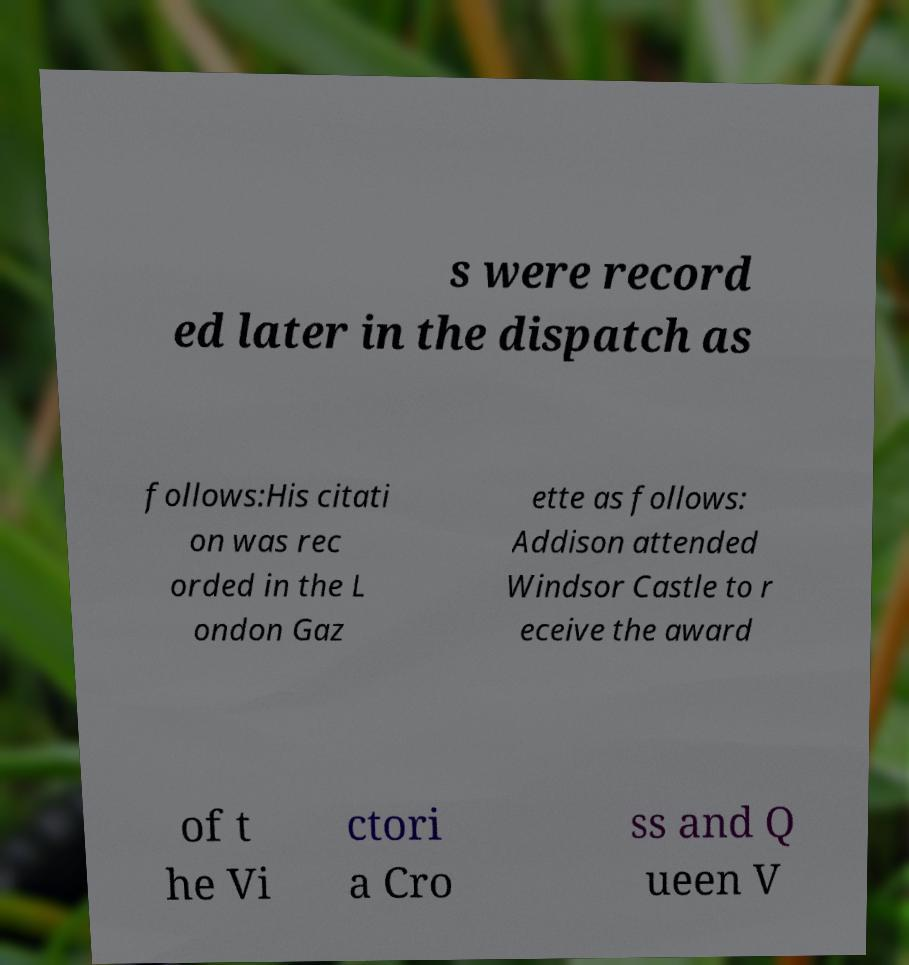I need the written content from this picture converted into text. Can you do that? s were record ed later in the dispatch as follows:His citati on was rec orded in the L ondon Gaz ette as follows: Addison attended Windsor Castle to r eceive the award of t he Vi ctori a Cro ss and Q ueen V 